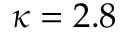<formula> <loc_0><loc_0><loc_500><loc_500>\kappa = 2 . 8</formula> 